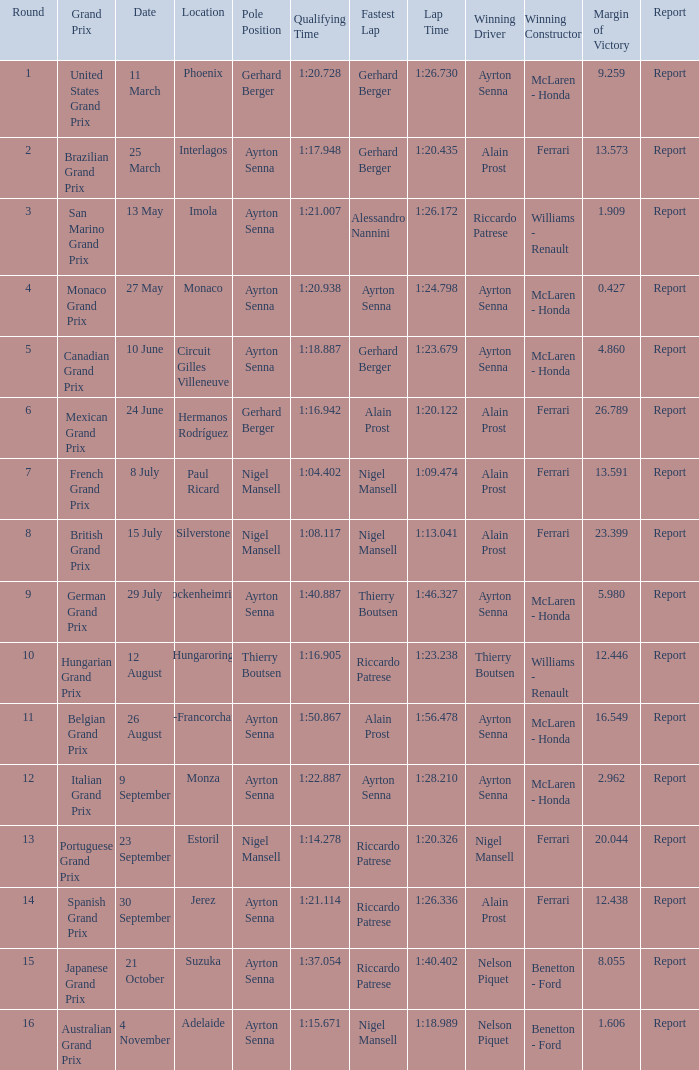What was the constructor when riccardo patrese was the winning driver? Williams - Renault. 